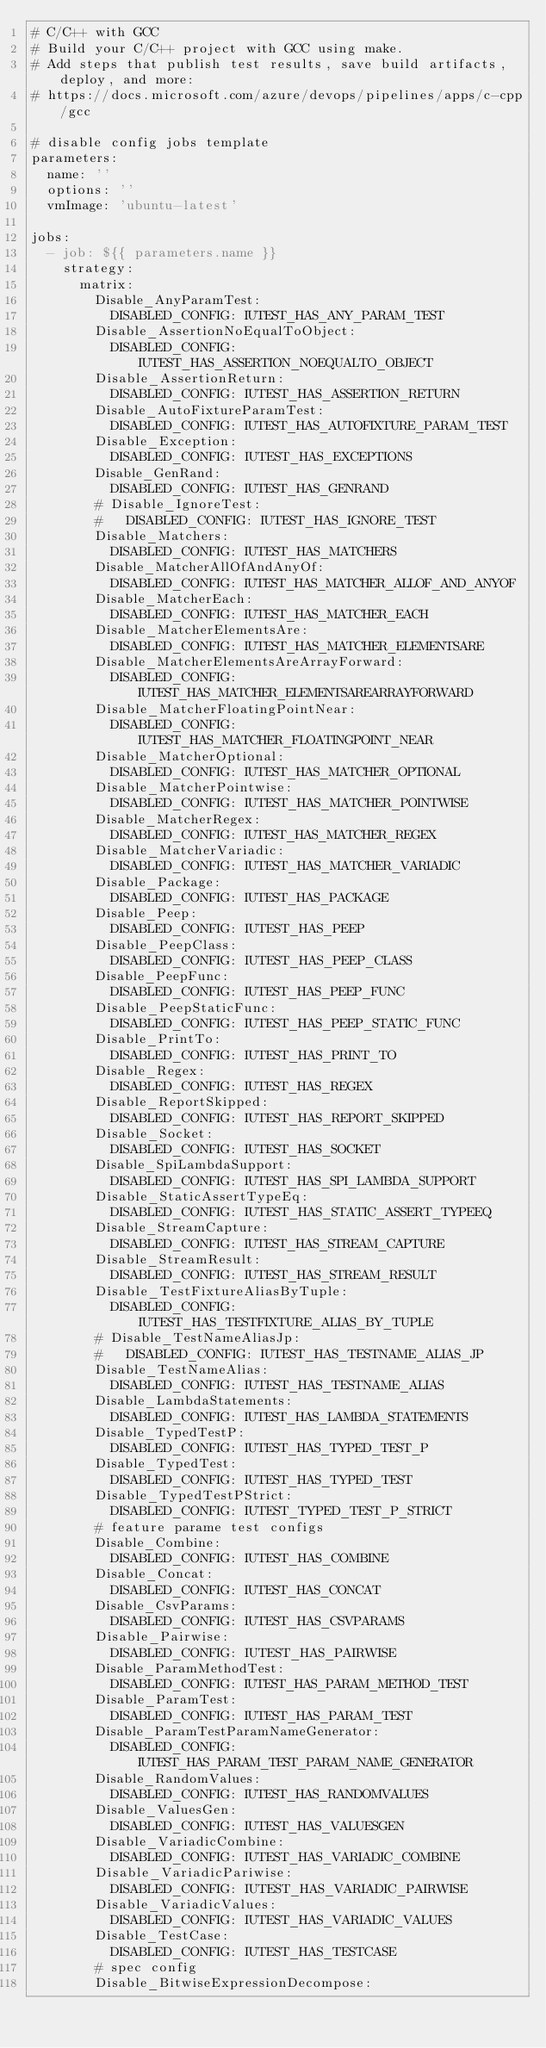<code> <loc_0><loc_0><loc_500><loc_500><_YAML_># C/C++ with GCC
# Build your C/C++ project with GCC using make.
# Add steps that publish test results, save build artifacts, deploy, and more:
# https://docs.microsoft.com/azure/devops/pipelines/apps/c-cpp/gcc

# disable config jobs template
parameters:
  name: ''
  options: ''
  vmImage: 'ubuntu-latest'

jobs:
  - job: ${{ parameters.name }}
    strategy:
      matrix:
        Disable_AnyParamTest:
          DISABLED_CONFIG: IUTEST_HAS_ANY_PARAM_TEST
        Disable_AssertionNoEqualToObject:
          DISABLED_CONFIG: IUTEST_HAS_ASSERTION_NOEQUALTO_OBJECT
        Disable_AssertionReturn:
          DISABLED_CONFIG: IUTEST_HAS_ASSERTION_RETURN
        Disable_AutoFixtureParamTest:
          DISABLED_CONFIG: IUTEST_HAS_AUTOFIXTURE_PARAM_TEST
        Disable_Exception:
          DISABLED_CONFIG: IUTEST_HAS_EXCEPTIONS
        Disable_GenRand:
          DISABLED_CONFIG: IUTEST_HAS_GENRAND
        # Disable_IgnoreTest:
        #   DISABLED_CONFIG: IUTEST_HAS_IGNORE_TEST
        Disable_Matchers:
          DISABLED_CONFIG: IUTEST_HAS_MATCHERS
        Disable_MatcherAllOfAndAnyOf:
          DISABLED_CONFIG: IUTEST_HAS_MATCHER_ALLOF_AND_ANYOF
        Disable_MatcherEach:
          DISABLED_CONFIG: IUTEST_HAS_MATCHER_EACH
        Disable_MatcherElementsAre:
          DISABLED_CONFIG: IUTEST_HAS_MATCHER_ELEMENTSARE
        Disable_MatcherElementsAreArrayForward:
          DISABLED_CONFIG: IUTEST_HAS_MATCHER_ELEMENTSAREARRAYFORWARD
        Disable_MatcherFloatingPointNear:
          DISABLED_CONFIG: IUTEST_HAS_MATCHER_FLOATINGPOINT_NEAR
        Disable_MatcherOptional:
          DISABLED_CONFIG: IUTEST_HAS_MATCHER_OPTIONAL
        Disable_MatcherPointwise:
          DISABLED_CONFIG: IUTEST_HAS_MATCHER_POINTWISE
        Disable_MatcherRegex:
          DISABLED_CONFIG: IUTEST_HAS_MATCHER_REGEX
        Disable_MatcherVariadic:
          DISABLED_CONFIG: IUTEST_HAS_MATCHER_VARIADIC
        Disable_Package:
          DISABLED_CONFIG: IUTEST_HAS_PACKAGE
        Disable_Peep:
          DISABLED_CONFIG: IUTEST_HAS_PEEP
        Disable_PeepClass:
          DISABLED_CONFIG: IUTEST_HAS_PEEP_CLASS
        Disable_PeepFunc:
          DISABLED_CONFIG: IUTEST_HAS_PEEP_FUNC
        Disable_PeepStaticFunc:
          DISABLED_CONFIG: IUTEST_HAS_PEEP_STATIC_FUNC
        Disable_PrintTo:
          DISABLED_CONFIG: IUTEST_HAS_PRINT_TO
        Disable_Regex:
          DISABLED_CONFIG: IUTEST_HAS_REGEX
        Disable_ReportSkipped:
          DISABLED_CONFIG: IUTEST_HAS_REPORT_SKIPPED
        Disable_Socket:
          DISABLED_CONFIG: IUTEST_HAS_SOCKET
        Disable_SpiLambdaSupport:
          DISABLED_CONFIG: IUTEST_HAS_SPI_LAMBDA_SUPPORT
        Disable_StaticAssertTypeEq:
          DISABLED_CONFIG: IUTEST_HAS_STATIC_ASSERT_TYPEEQ
        Disable_StreamCapture:
          DISABLED_CONFIG: IUTEST_HAS_STREAM_CAPTURE
        Disable_StreamResult:
          DISABLED_CONFIG: IUTEST_HAS_STREAM_RESULT
        Disable_TestFixtureAliasByTuple:
          DISABLED_CONFIG: IUTEST_HAS_TESTFIXTURE_ALIAS_BY_TUPLE
        # Disable_TestNameAliasJp:
        #   DISABLED_CONFIG: IUTEST_HAS_TESTNAME_ALIAS_JP
        Disable_TestNameAlias:
          DISABLED_CONFIG: IUTEST_HAS_TESTNAME_ALIAS
        Disable_LambdaStatements:
          DISABLED_CONFIG: IUTEST_HAS_LAMBDA_STATEMENTS
        Disable_TypedTestP:
          DISABLED_CONFIG: IUTEST_HAS_TYPED_TEST_P
        Disable_TypedTest:
          DISABLED_CONFIG: IUTEST_HAS_TYPED_TEST
        Disable_TypedTestPStrict:
          DISABLED_CONFIG: IUTEST_TYPED_TEST_P_STRICT
        # feature parame test configs
        Disable_Combine:
          DISABLED_CONFIG: IUTEST_HAS_COMBINE
        Disable_Concat:
          DISABLED_CONFIG: IUTEST_HAS_CONCAT
        Disable_CsvParams:
          DISABLED_CONFIG: IUTEST_HAS_CSVPARAMS
        Disable_Pairwise:
          DISABLED_CONFIG: IUTEST_HAS_PAIRWISE
        Disable_ParamMethodTest:
          DISABLED_CONFIG: IUTEST_HAS_PARAM_METHOD_TEST
        Disable_ParamTest:
          DISABLED_CONFIG: IUTEST_HAS_PARAM_TEST
        Disable_ParamTestParamNameGenerator:
          DISABLED_CONFIG: IUTEST_HAS_PARAM_TEST_PARAM_NAME_GENERATOR
        Disable_RandomValues:
          DISABLED_CONFIG: IUTEST_HAS_RANDOMVALUES
        Disable_ValuesGen:
          DISABLED_CONFIG: IUTEST_HAS_VALUESGEN
        Disable_VariadicCombine:
          DISABLED_CONFIG: IUTEST_HAS_VARIADIC_COMBINE
        Disable_VariadicPariwise:
          DISABLED_CONFIG: IUTEST_HAS_VARIADIC_PAIRWISE
        Disable_VariadicValues:
          DISABLED_CONFIG: IUTEST_HAS_VARIADIC_VALUES
        Disable_TestCase:
          DISABLED_CONFIG: IUTEST_HAS_TESTCASE
        # spec config
        Disable_BitwiseExpressionDecompose:</code> 